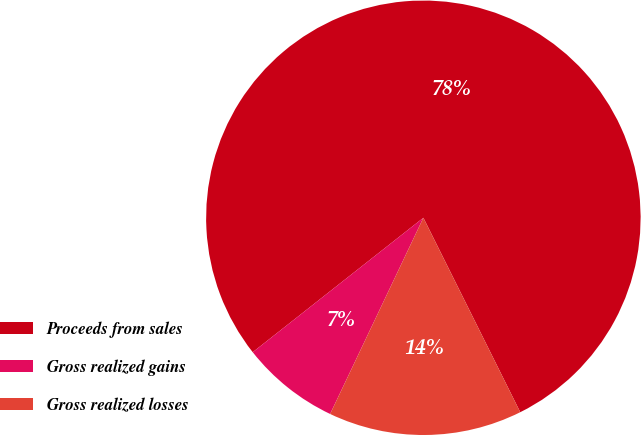Convert chart. <chart><loc_0><loc_0><loc_500><loc_500><pie_chart><fcel>Proceeds from sales<fcel>Gross realized gains<fcel>Gross realized losses<nl><fcel>78.26%<fcel>7.32%<fcel>14.42%<nl></chart> 